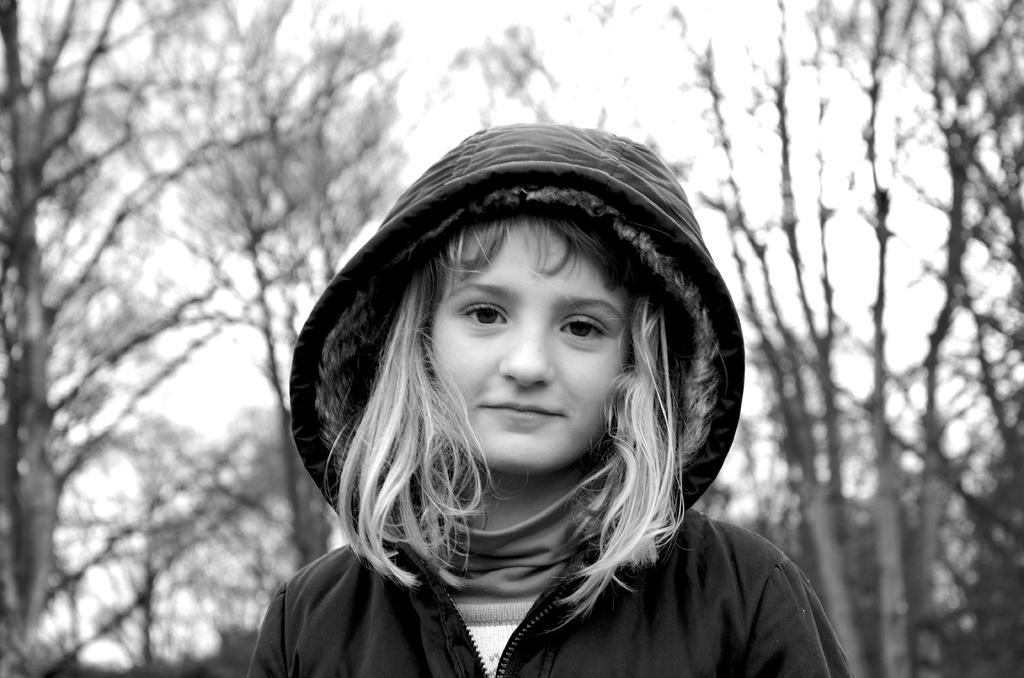What is the color scheme of the image? The image is black and white. Who or what is the main subject in the image? There is a girl in the image. What can be seen in the background of the image? There are trees and the sky visible in the background of the image. What type of wool is the girl wearing in the image? There is no wool visible in the image, as the image is black and white and does not show any clothing details. 